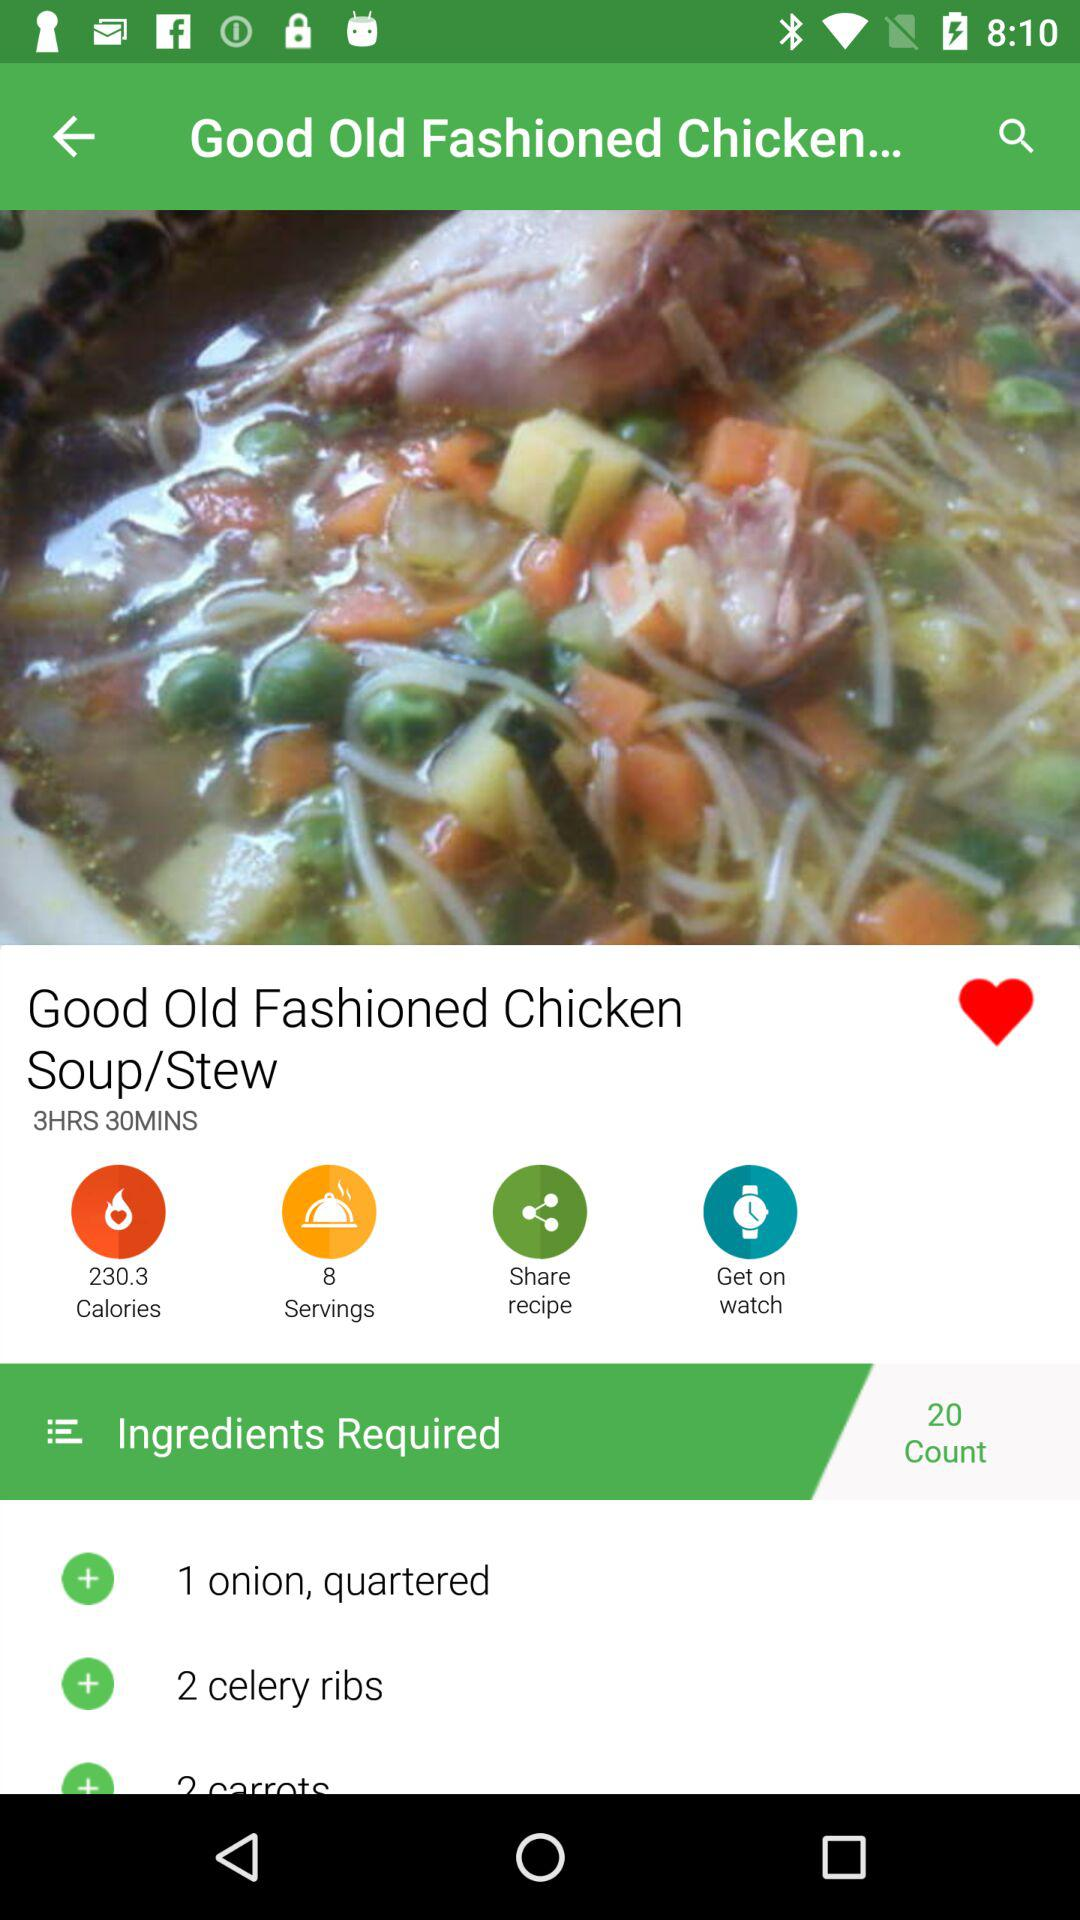How many calories are in the dish? There are 230.3 calories in the dish. 